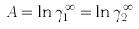<formula> <loc_0><loc_0><loc_500><loc_500>A = \ln \gamma _ { 1 } ^ { \infty } = \ln \gamma _ { 2 } ^ { \infty }</formula> 